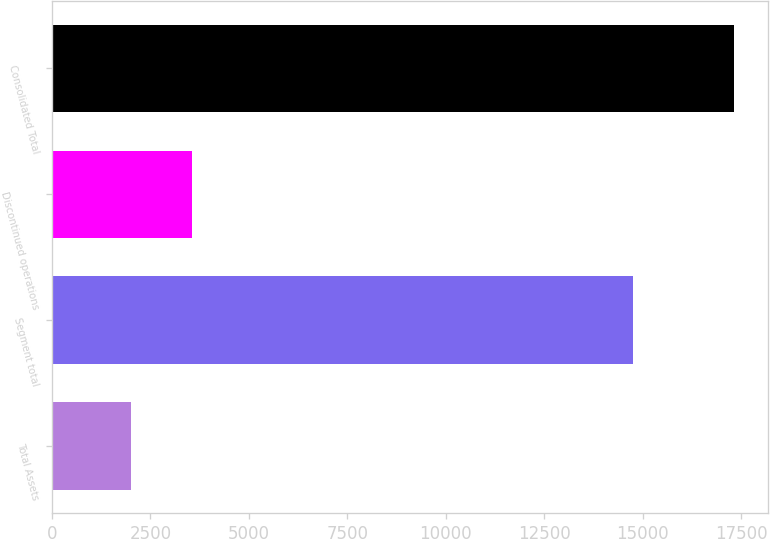Convert chart to OTSL. <chart><loc_0><loc_0><loc_500><loc_500><bar_chart><fcel>Total Assets<fcel>Segment total<fcel>Discontinued operations<fcel>Consolidated Total<nl><fcel>2015<fcel>14760<fcel>3545.16<fcel>17316.6<nl></chart> 